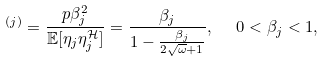Convert formula to latex. <formula><loc_0><loc_0><loc_500><loc_500>^ { ( j ) } = \frac { p \beta ^ { 2 } _ { j } } { \mathbb { E } [ \eta _ { j } \eta ^ { \mathcal { H } } _ { j } ] } = \frac { \beta _ { j } } { 1 - \frac { \beta _ { j } } { 2 \sqrt { \omega } + 1 } } , \ \ 0 < \beta _ { j } < 1 ,</formula> 